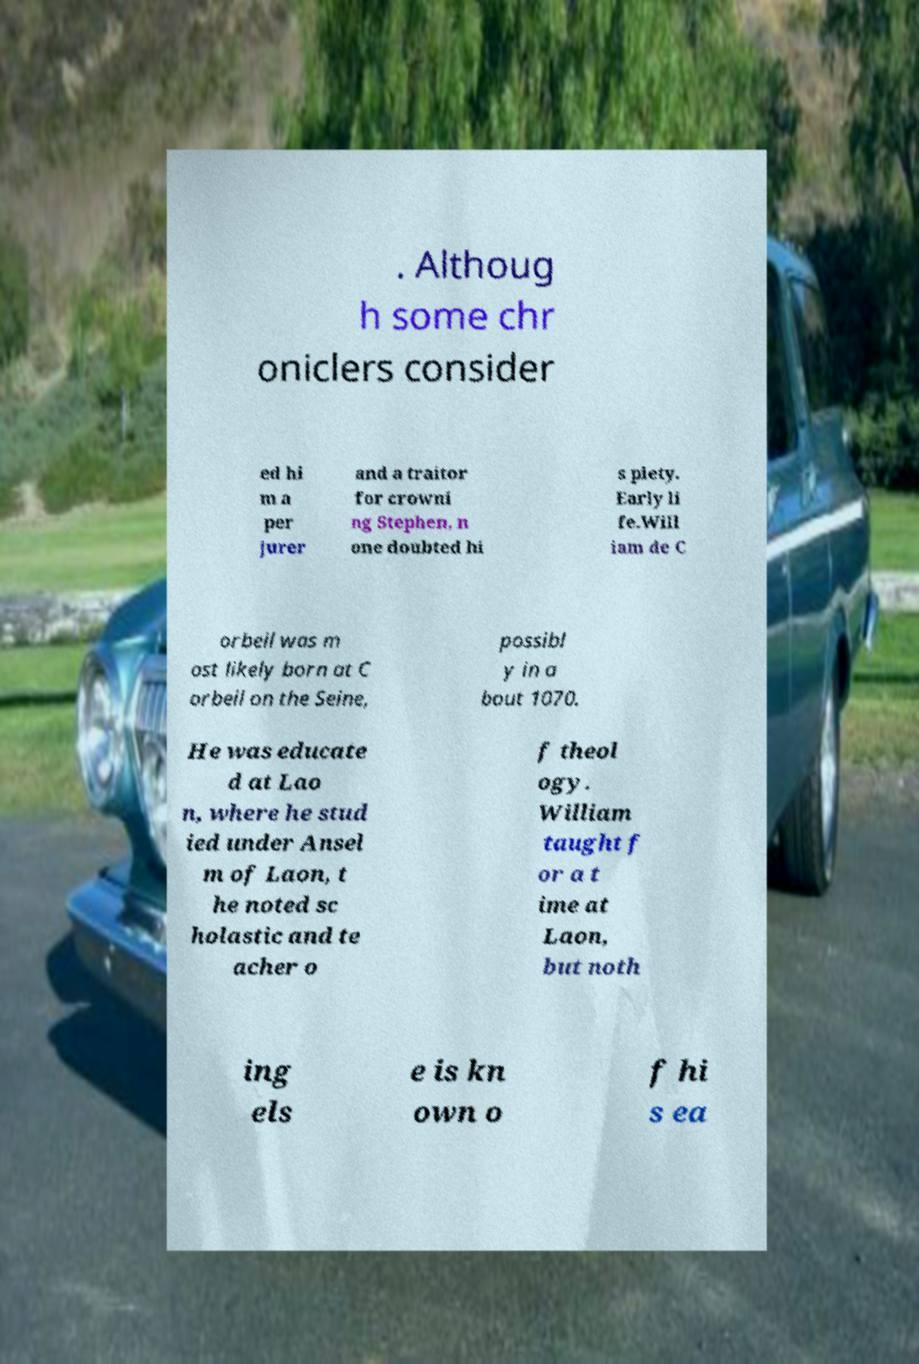Can you accurately transcribe the text from the provided image for me? . Althoug h some chr oniclers consider ed hi m a per jurer and a traitor for crowni ng Stephen, n one doubted hi s piety. Early li fe.Will iam de C orbeil was m ost likely born at C orbeil on the Seine, possibl y in a bout 1070. He was educate d at Lao n, where he stud ied under Ansel m of Laon, t he noted sc holastic and te acher o f theol ogy. William taught f or a t ime at Laon, but noth ing els e is kn own o f hi s ea 